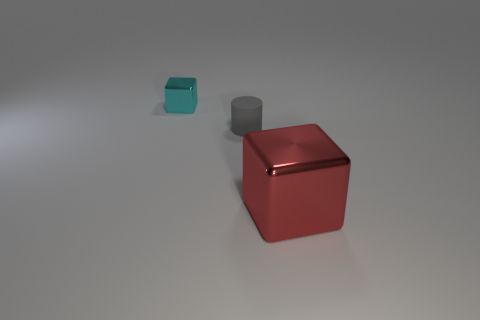Add 3 large purple rubber cylinders. How many objects exist? 6 Subtract all cylinders. How many objects are left? 2 Subtract 0 brown cubes. How many objects are left? 3 Subtract all small objects. Subtract all big purple cylinders. How many objects are left? 1 Add 3 tiny matte cylinders. How many tiny matte cylinders are left? 4 Add 1 small cylinders. How many small cylinders exist? 2 